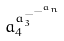<formula> <loc_0><loc_0><loc_500><loc_500>a _ { 4 } ^ { a _ { 3 } ^ { - ^ { - ^ { a _ { n } } } } }</formula> 